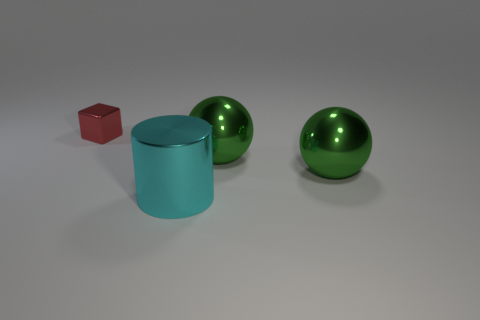What number of green objects are the same size as the cyan metal cylinder?
Keep it short and to the point. 2. There is a object that is left of the large shiny cylinder; how many large green balls are on the right side of it?
Provide a succinct answer. 2. How many large green balls are to the right of the tiny metal block?
Make the answer very short. 2. The red object is what shape?
Your answer should be very brief. Cube. How many things are either small yellow rubber spheres or large shiny balls?
Provide a short and direct response. 2. How many other things are the same shape as the red metal object?
Keep it short and to the point. 0. Are any shiny spheres visible?
Give a very brief answer. Yes. How many things are cyan metallic objects or metal objects that are behind the cyan cylinder?
Your answer should be very brief. 4. How many other objects are there of the same size as the cyan object?
Keep it short and to the point. 2. What color is the small cube?
Your response must be concise. Red. 